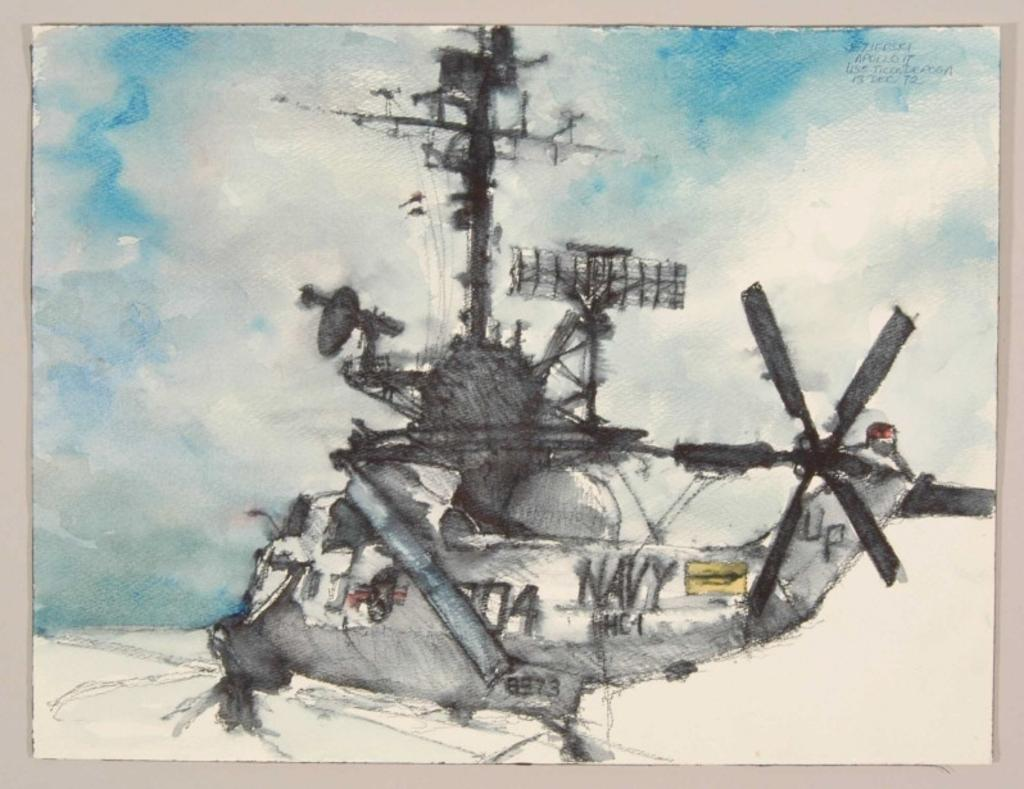<image>
Render a clear and concise summary of the photo. A sketch of a Navy helicopter is done mostly in black and gray, but also features some blue coloring. 